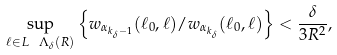Convert formula to latex. <formula><loc_0><loc_0><loc_500><loc_500>\sup _ { \ell \in L \ \Lambda _ { \delta } ( R ) } \left \{ w _ { \alpha _ { k _ { \delta } - 1 } } ( \ell _ { 0 } , \ell ) / w _ { \alpha _ { k _ { \delta } } } ( \ell _ { 0 } , \ell ) \right \} < \frac { \delta } { 3 R ^ { 2 } } ,</formula> 